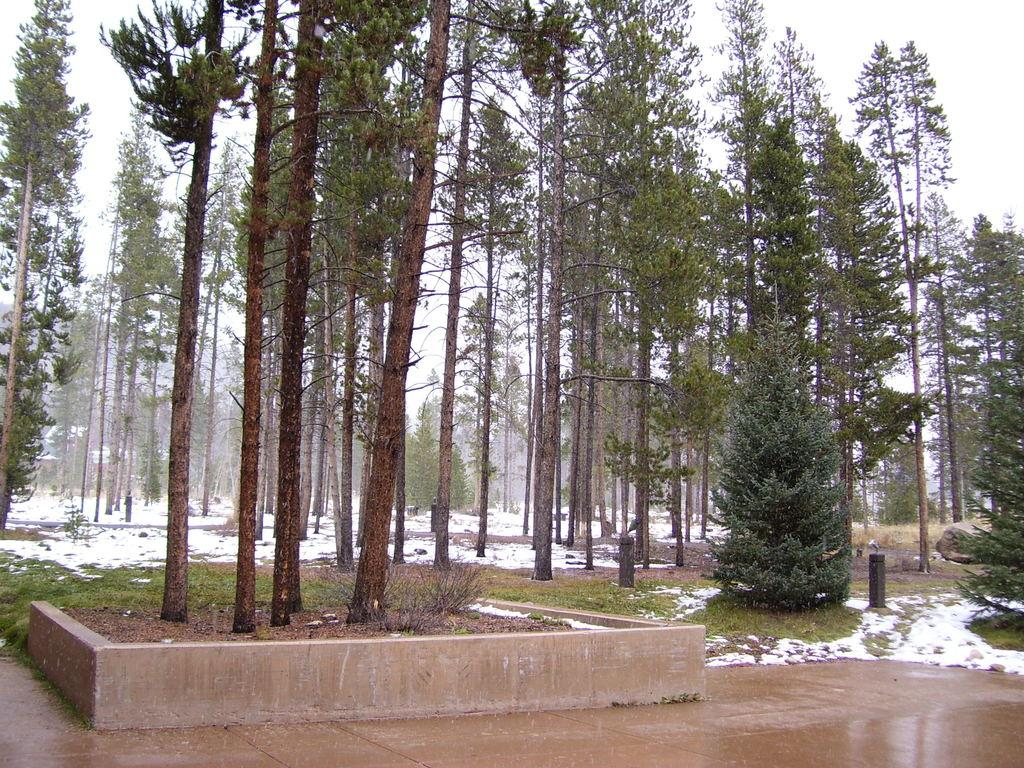What type of vegetation is present in the image? There are trees and grass in the image. What is covering the ground in the image? There is snow on the ground in the image. Can you tell me which eye of the farmer is missing in the image? There is no farmer present in the image, and therefore no missing eye can be observed. 